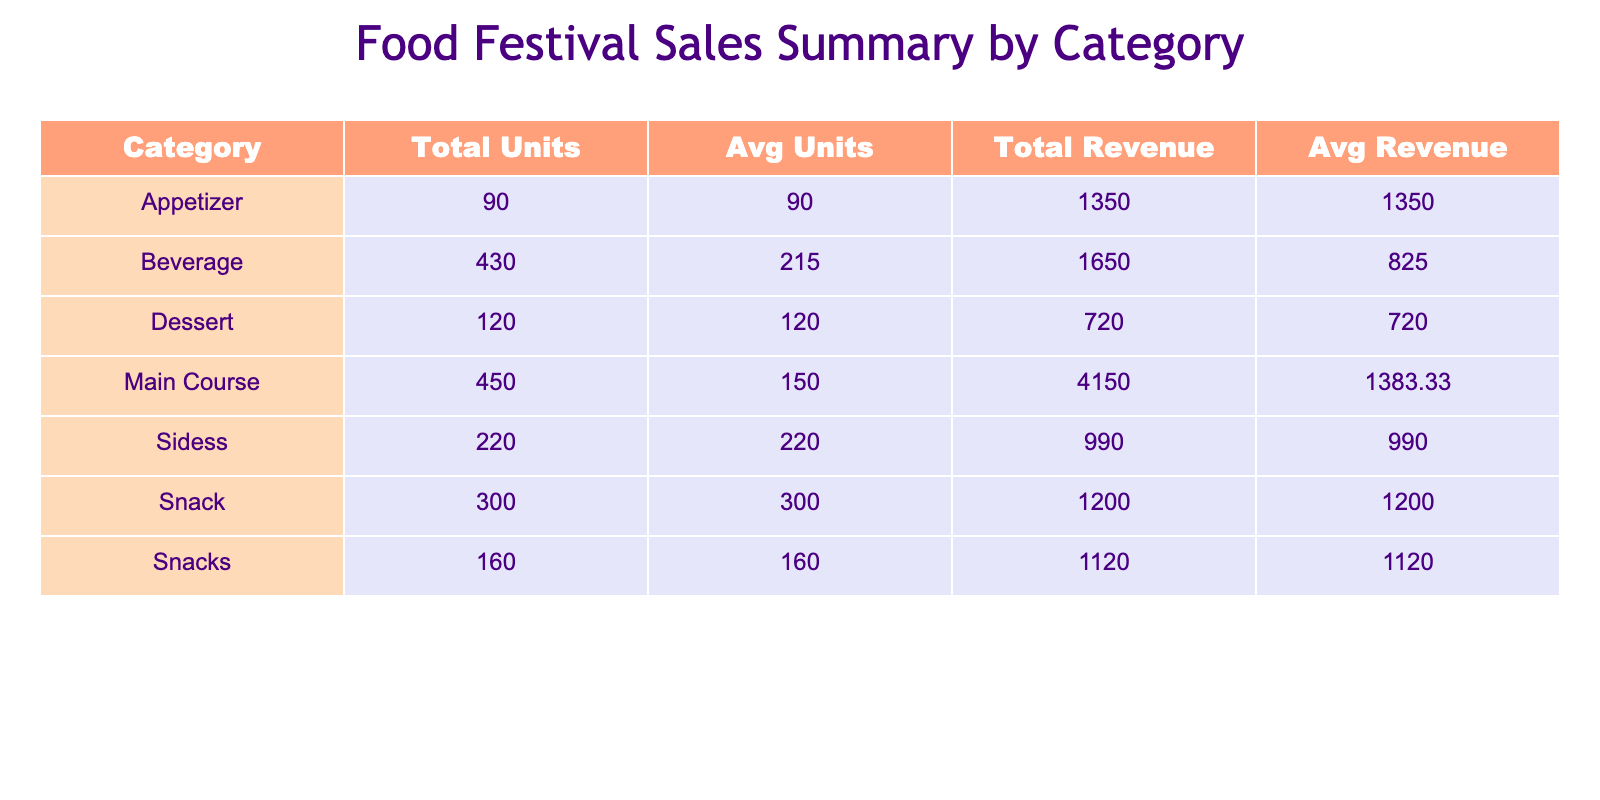What food item sold the most units? The table shows the food items along with their units sold. By looking at the "UnitsSold" column, Kettle Corn has the highest value at 300 units, making it the top-selling item.
Answer: Kettle Corn What is the total revenue from all dessert items? The dessert items listed are Chocolate Lava Cake. The total revenue for this item is 720. Since it's the only dessert, the total revenue for desserts is simply 720.
Answer: 720 Which beverage had a higher average revenue per unit, Craft Beer or Fresh Lemonade? Craft Beer has a price of 5.00 and sold 180 units, leading to a total revenue of 900, while Fresh Lemonade has a price of 3.00 and sold 250 units, with a total revenue of 750. The average revenue for Craft Beer is 900/180 = 5.00 and for Fresh Lemonade it is 750/250 = 3.00. Since 5.00 > 3.00, Craft Beer has the higher average revenue per unit.
Answer: Craft Beer How many total units were sold in the appetizer category? Only one appetizer is listed, which is the Gourmet Cheese Platter with 90 units sold. Therefore, the total units sold in the appetizer category is simply 90.
Answer: 90 Is the total revenue from Main Course items greater than the total revenue from Snacks? The total revenue from Main Courses, which includes Gourmet Burgers (2000), Artisan Tacos (1200), and Vegan Buddha Bowls (950), adds up to 2000 + 1200 + 950 = 4150. Snacks include Savory Crepes (1120) and Kettle Corn (1200), summing to 1120 + 1200 = 2320. Since 4150 > 2320, the total revenue from Main Course items is indeed greater.
Answer: Yes What is the average number of units sold across all beverage items? The beverage items listed are Craft Beer (180) and Fresh Lemonade (250). To find the average, we sum the units sold: 180 + 250 = 430, then divide by the number of beverage items, which is 2. Thus, the average units sold is 430/2 = 215.
Answer: 215 What is the total revenue generated from snacks? The snack items listed are Savory Crepes (1120) and Kettle Corn (1200). To find the total revenue from snacks, we add these together: 1120 + 1200 = 2320.
Answer: 2320 Which food category had the highest total revenue? By examining the total revenue for each category, we find: Main Course total revenue is 4150, Dessert is 720, Beverages is 1650 and Snacks is 2320. The highest total revenue is from the Main Course category with 4150.
Answer: Main Course Did Vegan Buddha Bowls generate more revenue than Gourmet Cheese Platter? The total revenue for Vegan Buddha Bowls is 950, while for Gourmet Cheese Platter it is 1350. Since 950 < 1350, Vegan Buddha Bowls did not generate more revenue.
Answer: No 